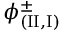<formula> <loc_0><loc_0><loc_500><loc_500>\phi _ { ( { I I } , { I } ) } ^ { \pm }</formula> 